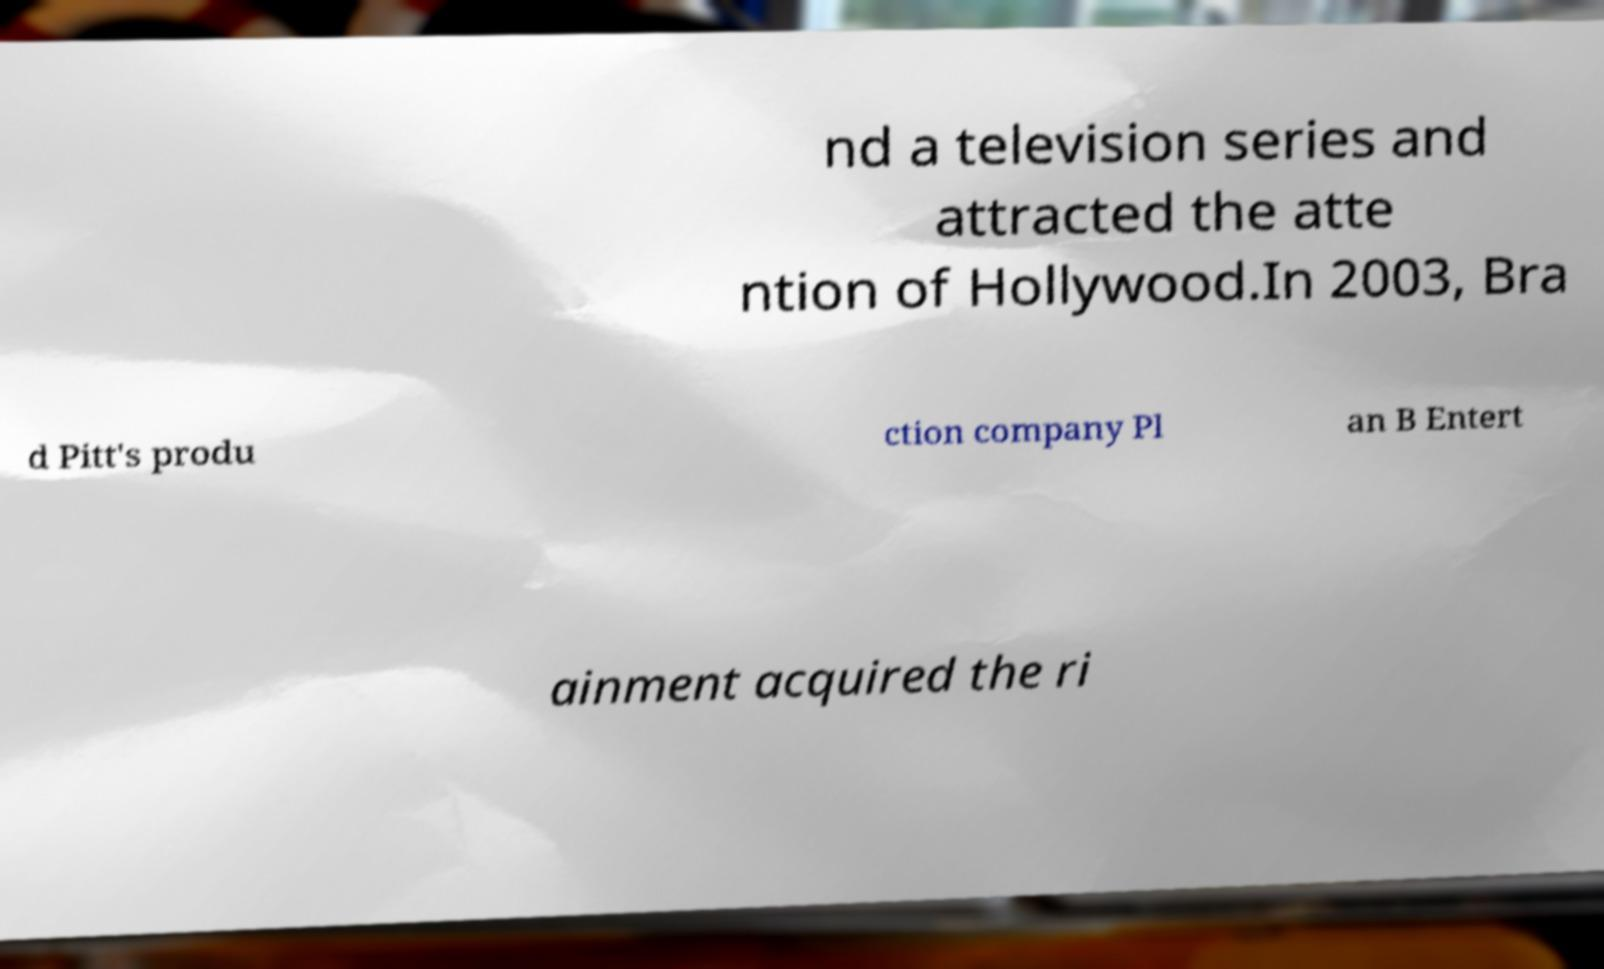Please identify and transcribe the text found in this image. nd a television series and attracted the atte ntion of Hollywood.In 2003, Bra d Pitt's produ ction company Pl an B Entert ainment acquired the ri 